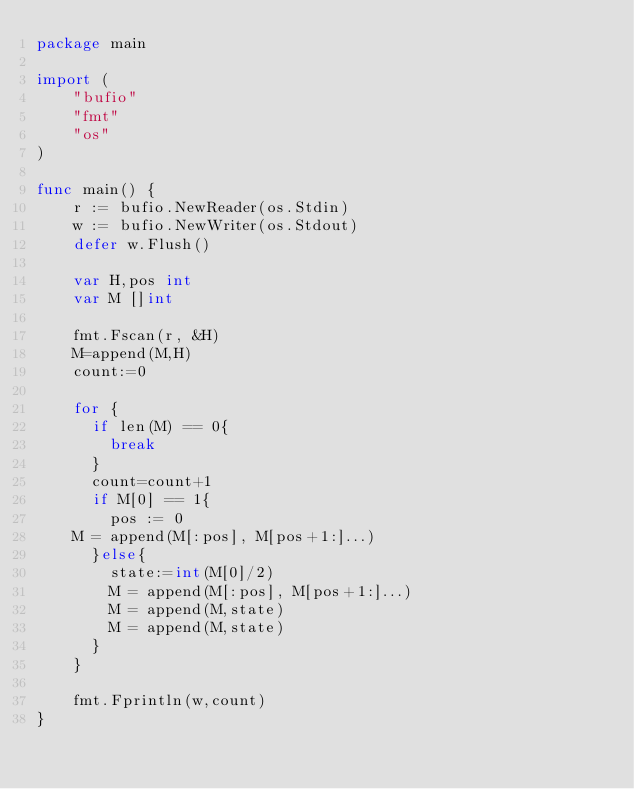Convert code to text. <code><loc_0><loc_0><loc_500><loc_500><_Go_>package main

import (
    "bufio"
    "fmt"
    "os"
)

func main() {
    r := bufio.NewReader(os.Stdin)
    w := bufio.NewWriter(os.Stdout)
    defer w.Flush()

    var H,pos int
  	var M []int

    fmt.Fscan(r, &H)
  	M=append(M,H)
  	count:=0
  
    for {
      if len(M) == 0{
        break
      }
      count=count+1
      if M[0] == 1{
        pos := 0
		M = append(M[:pos], M[pos+1:]...)
      }else{
        state:=int(M[0]/2)
        M = append(M[:pos], M[pos+1:]...)
        M = append(M,state)
        M = append(M,state)       
      }
    }

    fmt.Fprintln(w,count)
}</code> 